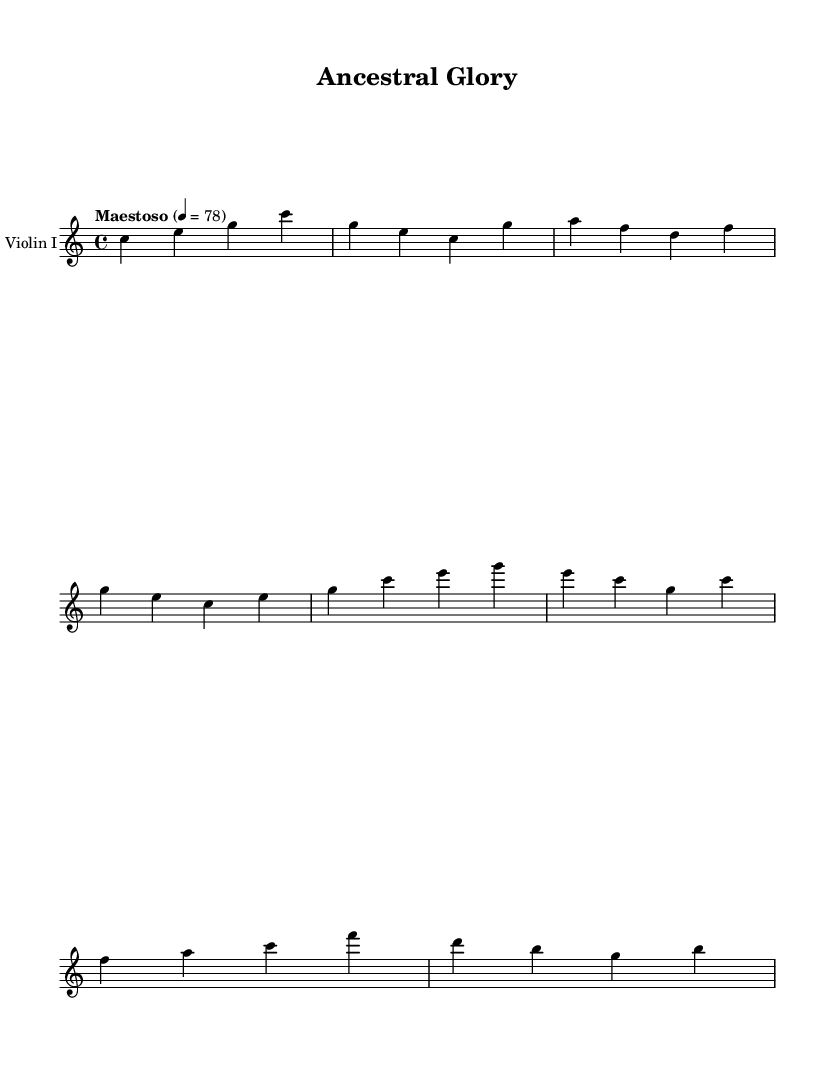What is the key signature of this music? The key signature is C major, which has no sharps or flats.
Answer: C major What is the time signature of the composition? The time signature is indicated as 4/4, meaning there are four beats in each measure.
Answer: 4/4 What is the tempo marking of the piece? The tempo marking is "Maestoso," indicating a majestic and stately pace, set to 4 beats per minute at 78.
Answer: Maestoso How many measures are there in the violin part? Counting the measures in the violin part, there are 8 measures total.
Answer: 8 What is the highest note played in this excerpt? By analyzing the notes, the highest note in the excerpt is g'.
Answer: g' What type of musical form is being used in this piece? The piece appears to follow a simple melodic structure typical of thematic classical works, focusing on development rather than a strict form.
Answer: Theme 